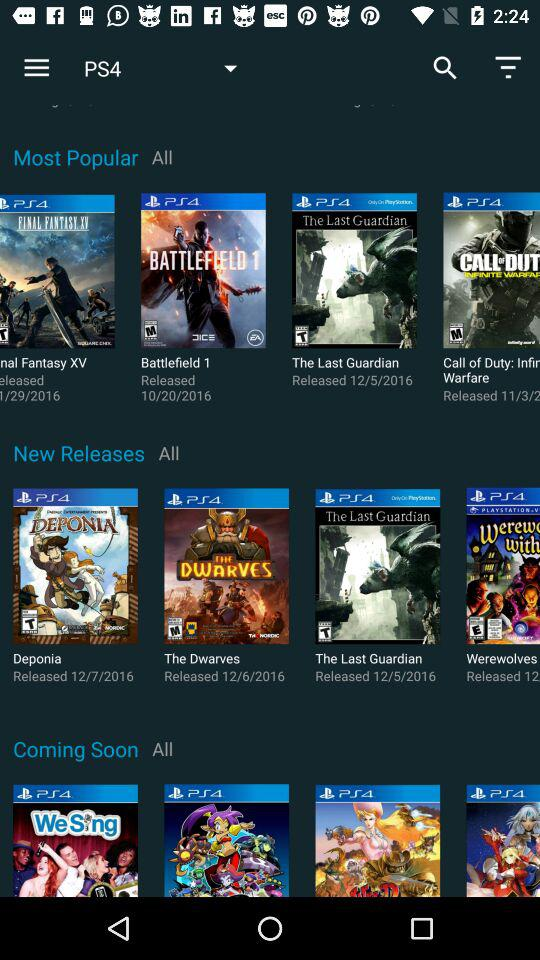What is the release date of "The Last Guardian"? The release date is December 5, 2016. 